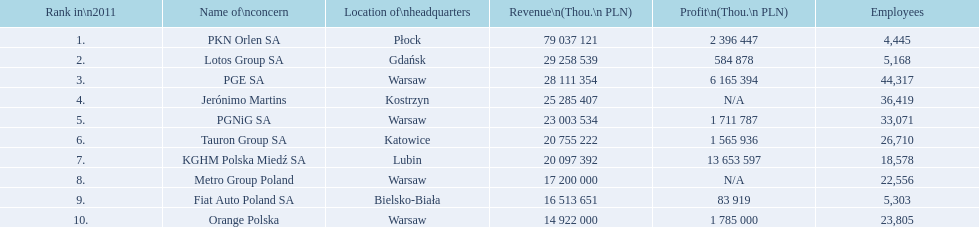Which company had the least revenue? Orange Polska. 